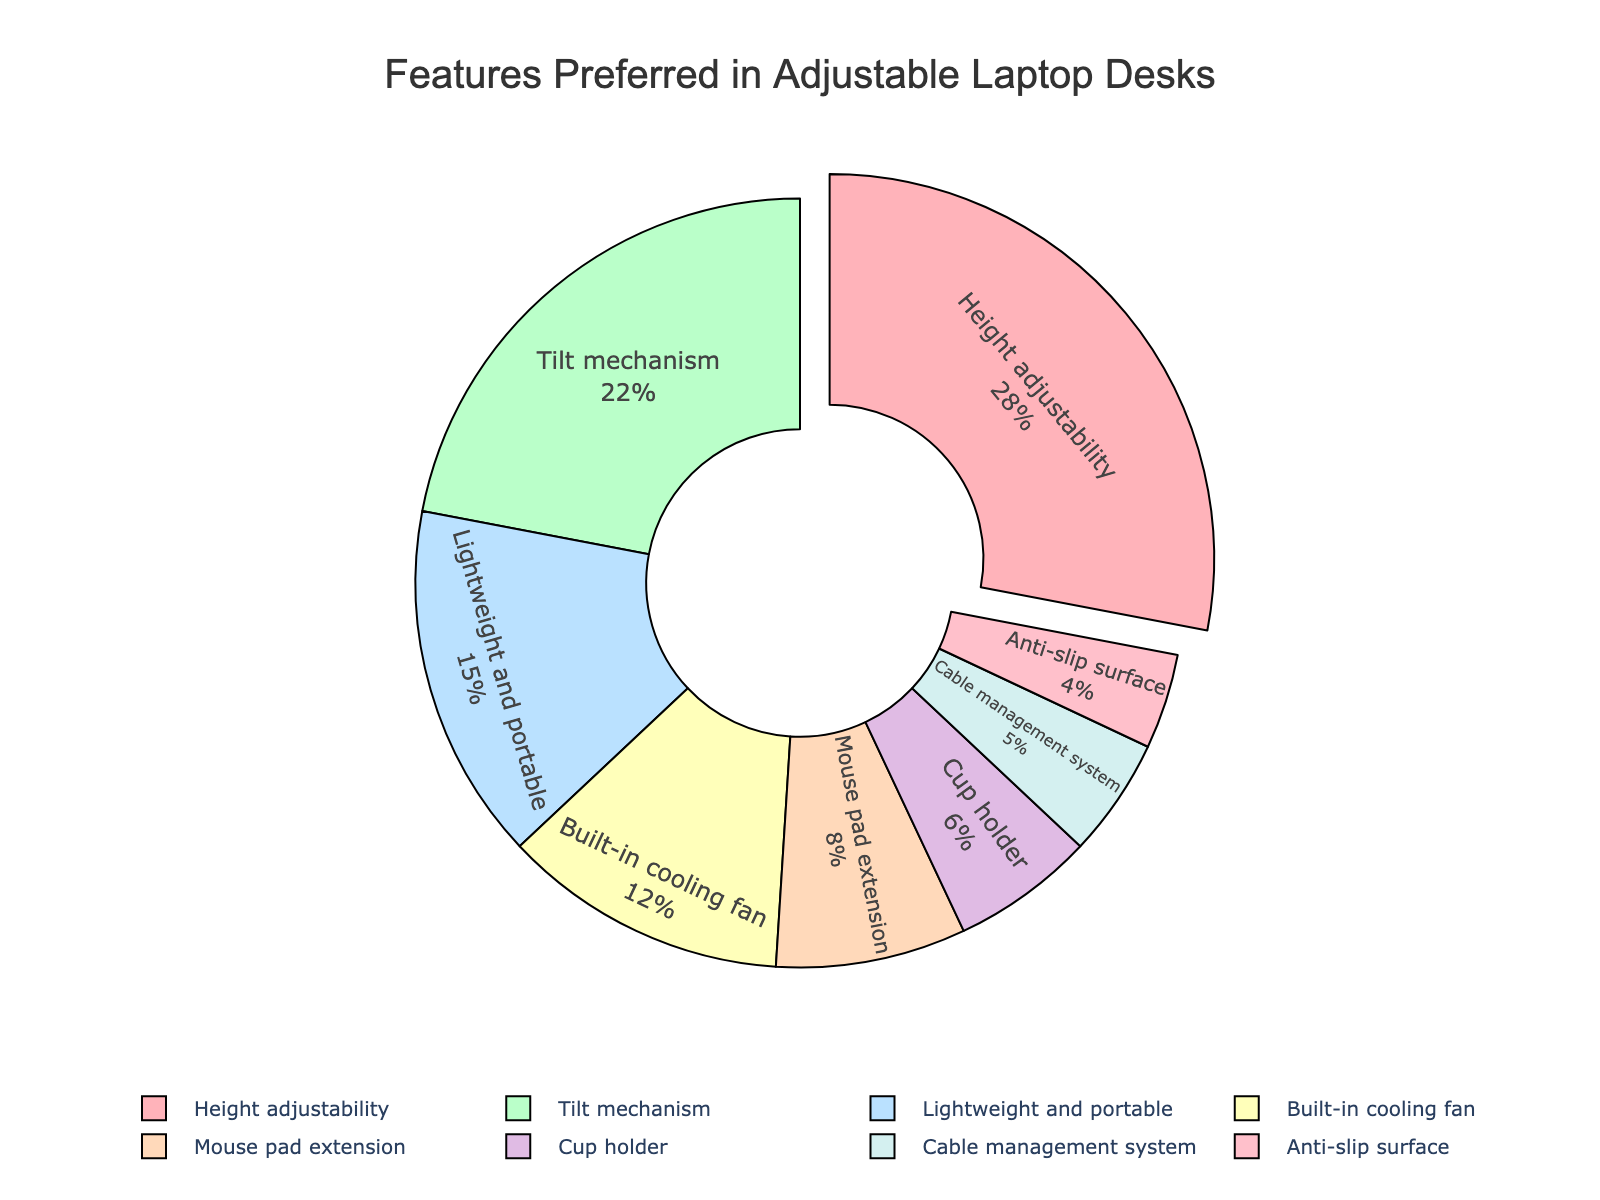What feature is preferred by the highest percentage of users? From the pie chart, observe the section that stands out the most due to its large size and the fact that it's slightly pulled out. This represents the feature with the highest percentage, which is "Height adjustability" at 28%.
Answer: Height adjustability What is the combined percentage of users who prefer a built-in cooling fan and a mouse pad extension? Refer to the sizes of the segments labeled "Built-in cooling fan" and "Mouse pad extension". The percentages are 12% and 8%, respectively. Add these two numbers together: 12% + 8% = 20%.
Answer: 20% Which feature has the smallest percentage of user preference, and what is that percentage? Look for the smallest segment in the pie chart. The smallest segment is for "Anti-slip surface," which has a percentage of 4%.
Answer: Anti-slip surface, 4% How much greater is the preference for height adjustability compared to cup holders? Identify the segments for "Height adjustability" and "Cup holder." The percentages are 28% and 6%, respectively. Subtract the smaller percentage from the larger one: 28% - 6% = 22%.
Answer: 22% Which two features, when combined, are preferred by the same percentage as the tilt mechanism? Locate the segment for "Tilt mechanism" which is 22%. Find combinations of other segments that sum up to 22%. The segments for "Lightweight and portable" and "Anti-slip surface" are 15% and 4%, respectively, summing to 15% + 4% = 19%. Instead, "Mouse pad extension" 8% and "Cup holder" 6% sum together as 8% + 6% = 14%. Finally, "Lightweight and portable" 15% and "Built-in cooling fan" 12% sum to 27%. Thus, "Cup holder" 6% and "Cable management system" 5% sum up to the category equal or closer to tilt mechanism preference standing at 22%.
Answer: None 